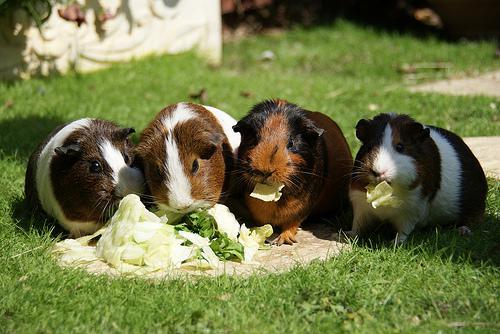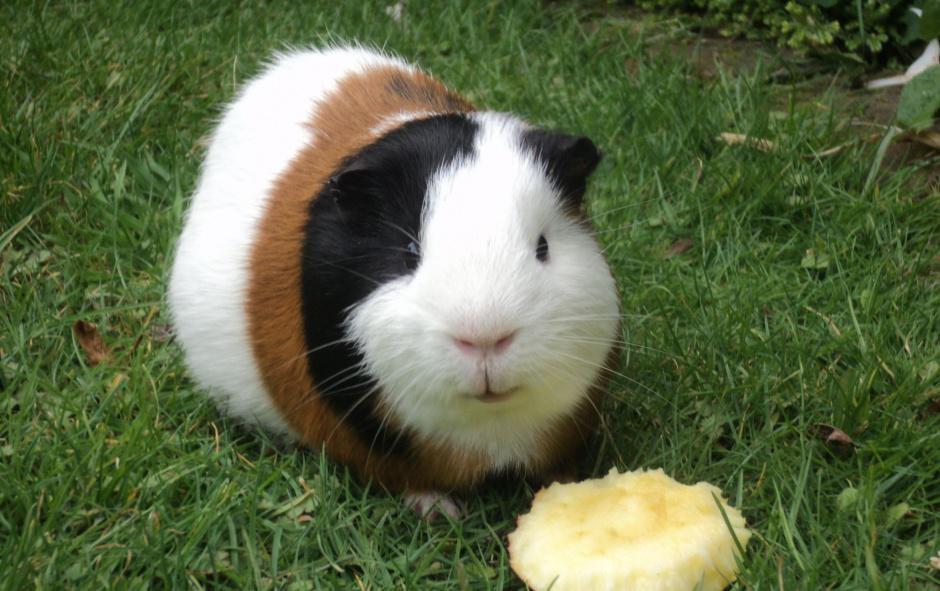The first image is the image on the left, the second image is the image on the right. Evaluate the accuracy of this statement regarding the images: "Two gerbils are in a wire pen.". Is it true? Answer yes or no. No. The first image is the image on the left, the second image is the image on the right. Analyze the images presented: Is the assertion "There are 5 hamsters in the grass." valid? Answer yes or no. Yes. 